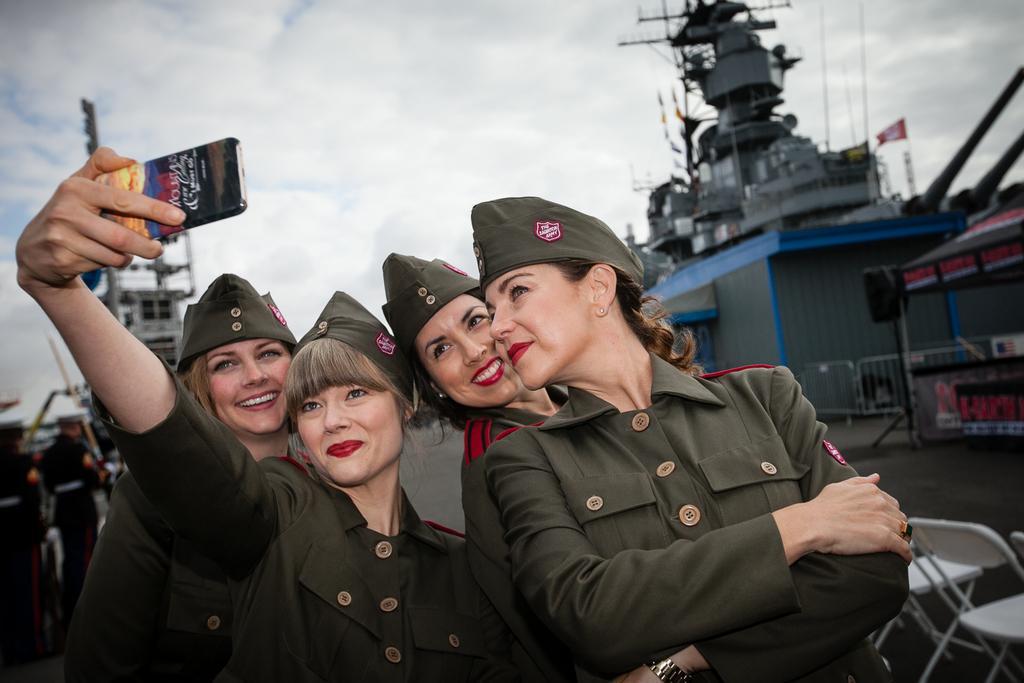Can you describe this image briefly? This picture is clicked outside. In the foreground we can see the group of persons wearing uniforms, smiling and standing. In the background we can see the tents and many other objects and we can see the sky which is full of clouds and we can see the chairs placed on the ground and there is a person holding a mobile and seems to be taking pictures. 